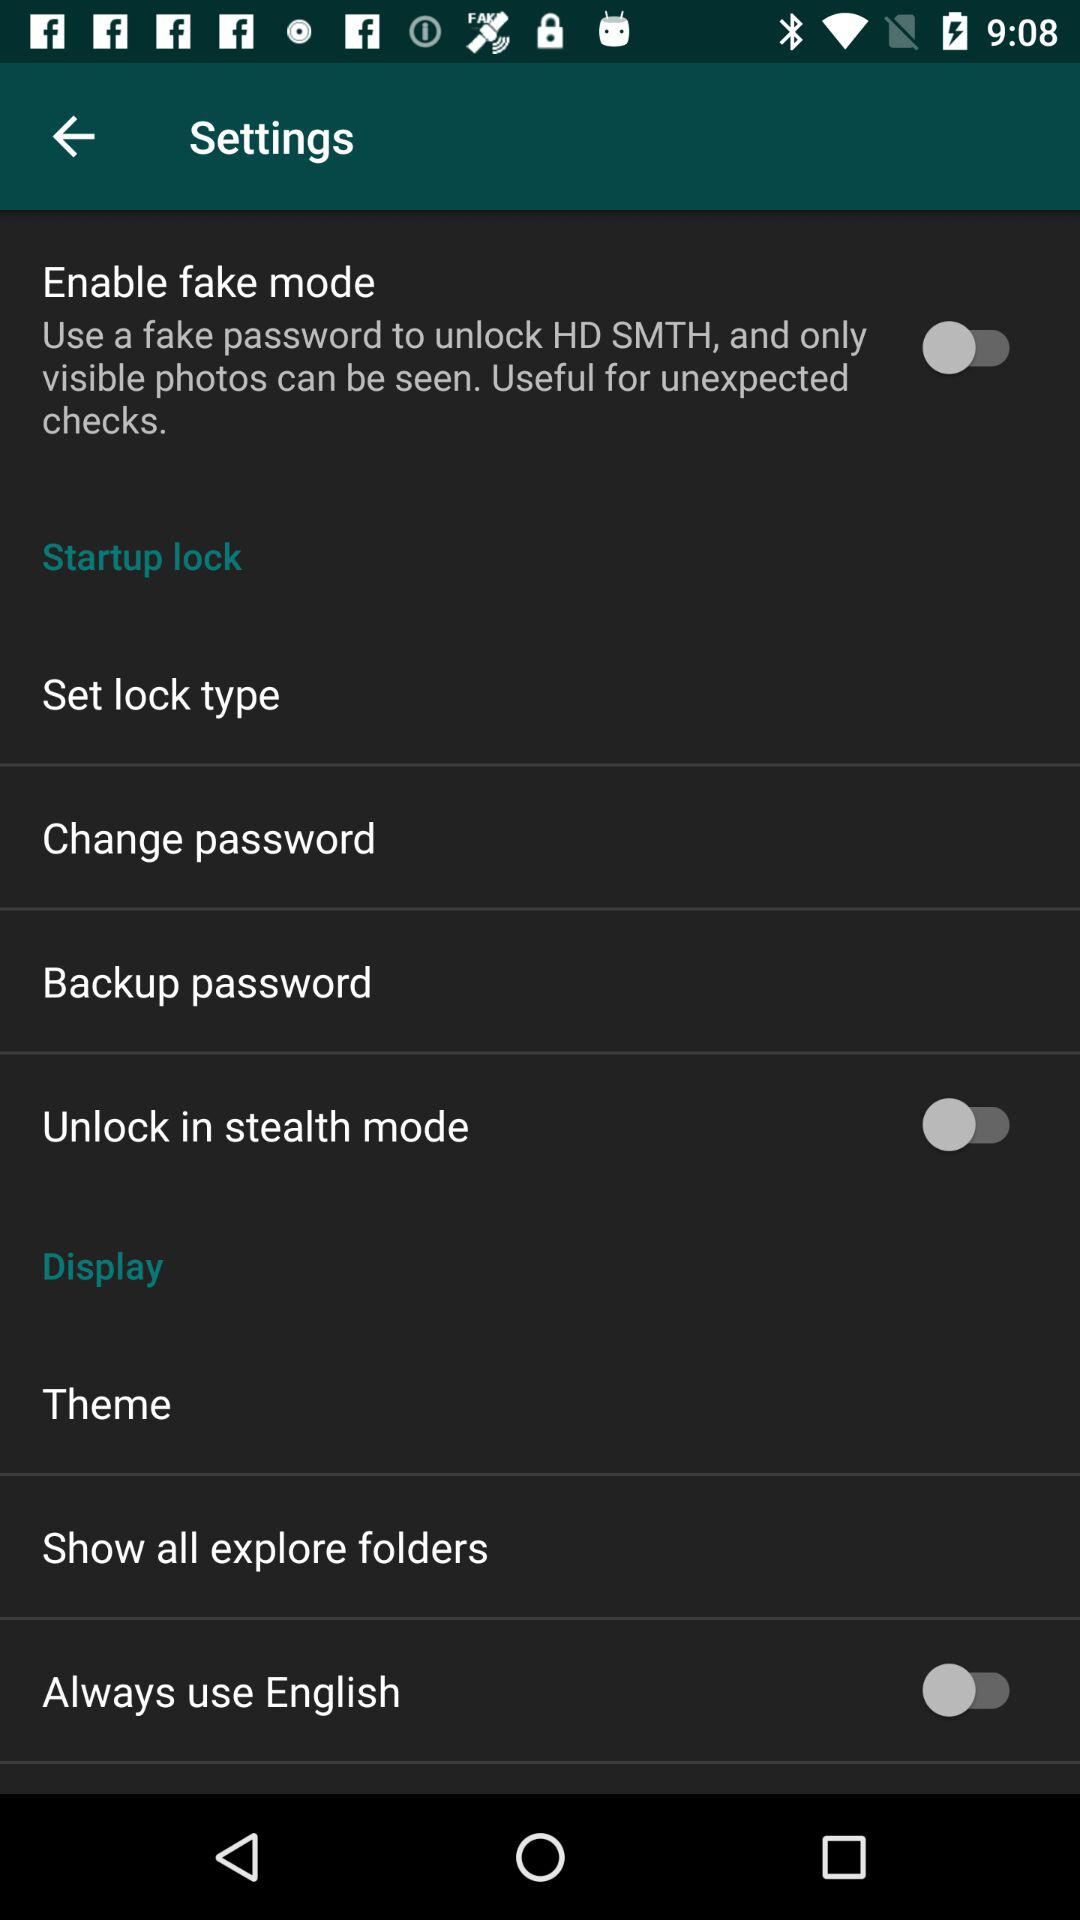What is the status of "Enable fake mode"? The status is "off". 